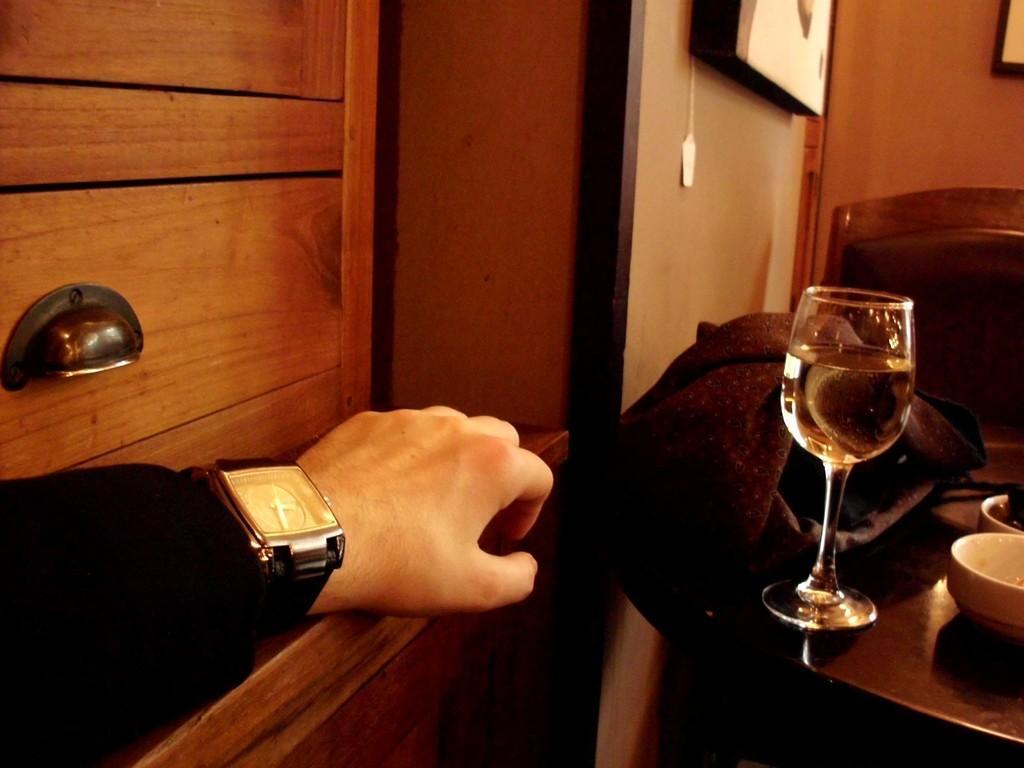How would you summarize this image in a sentence or two? In this picture we can see a person's hand, glass with drink in it, cloth, bowls, some objects and in the background we can see a frame on the wall. 